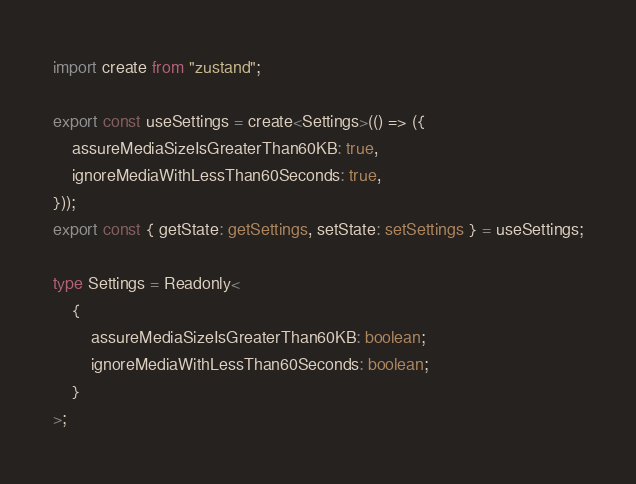<code> <loc_0><loc_0><loc_500><loc_500><_TypeScript_>import create from "zustand";

export const useSettings = create<Settings>(() => ({
	assureMediaSizeIsGreaterThan60KB: true,
	ignoreMediaWithLessThan60Seconds: true,
}));
export const { getState: getSettings, setState: setSettings } = useSettings;

type Settings = Readonly<
	{
		assureMediaSizeIsGreaterThan60KB: boolean;
		ignoreMediaWithLessThan60Seconds: boolean;
	}
>;
</code> 